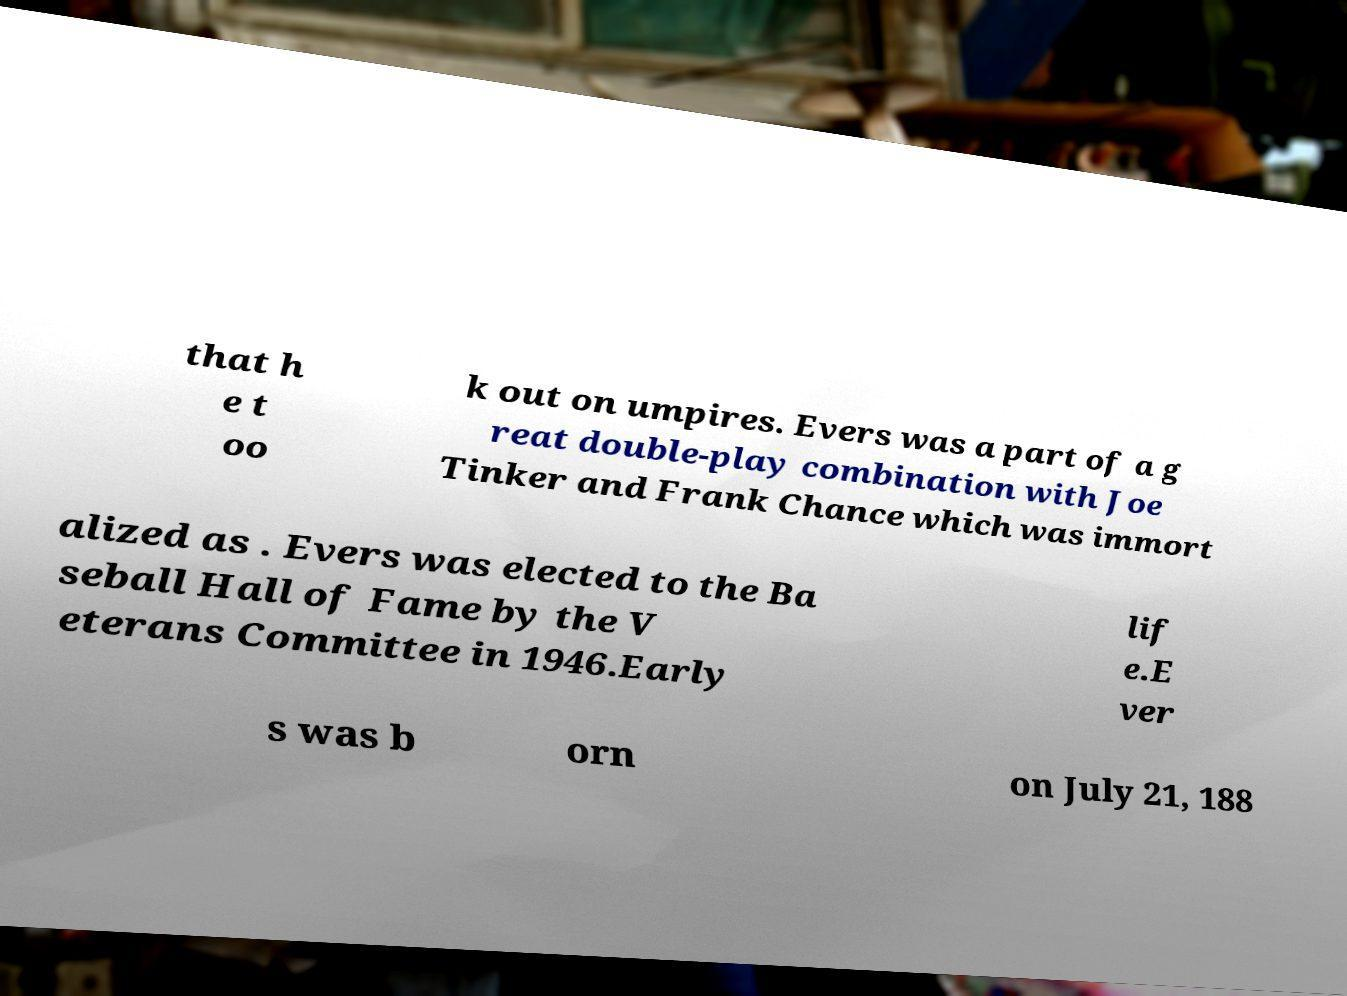Can you accurately transcribe the text from the provided image for me? that h e t oo k out on umpires. Evers was a part of a g reat double-play combination with Joe Tinker and Frank Chance which was immort alized as . Evers was elected to the Ba seball Hall of Fame by the V eterans Committee in 1946.Early lif e.E ver s was b orn on July 21, 188 